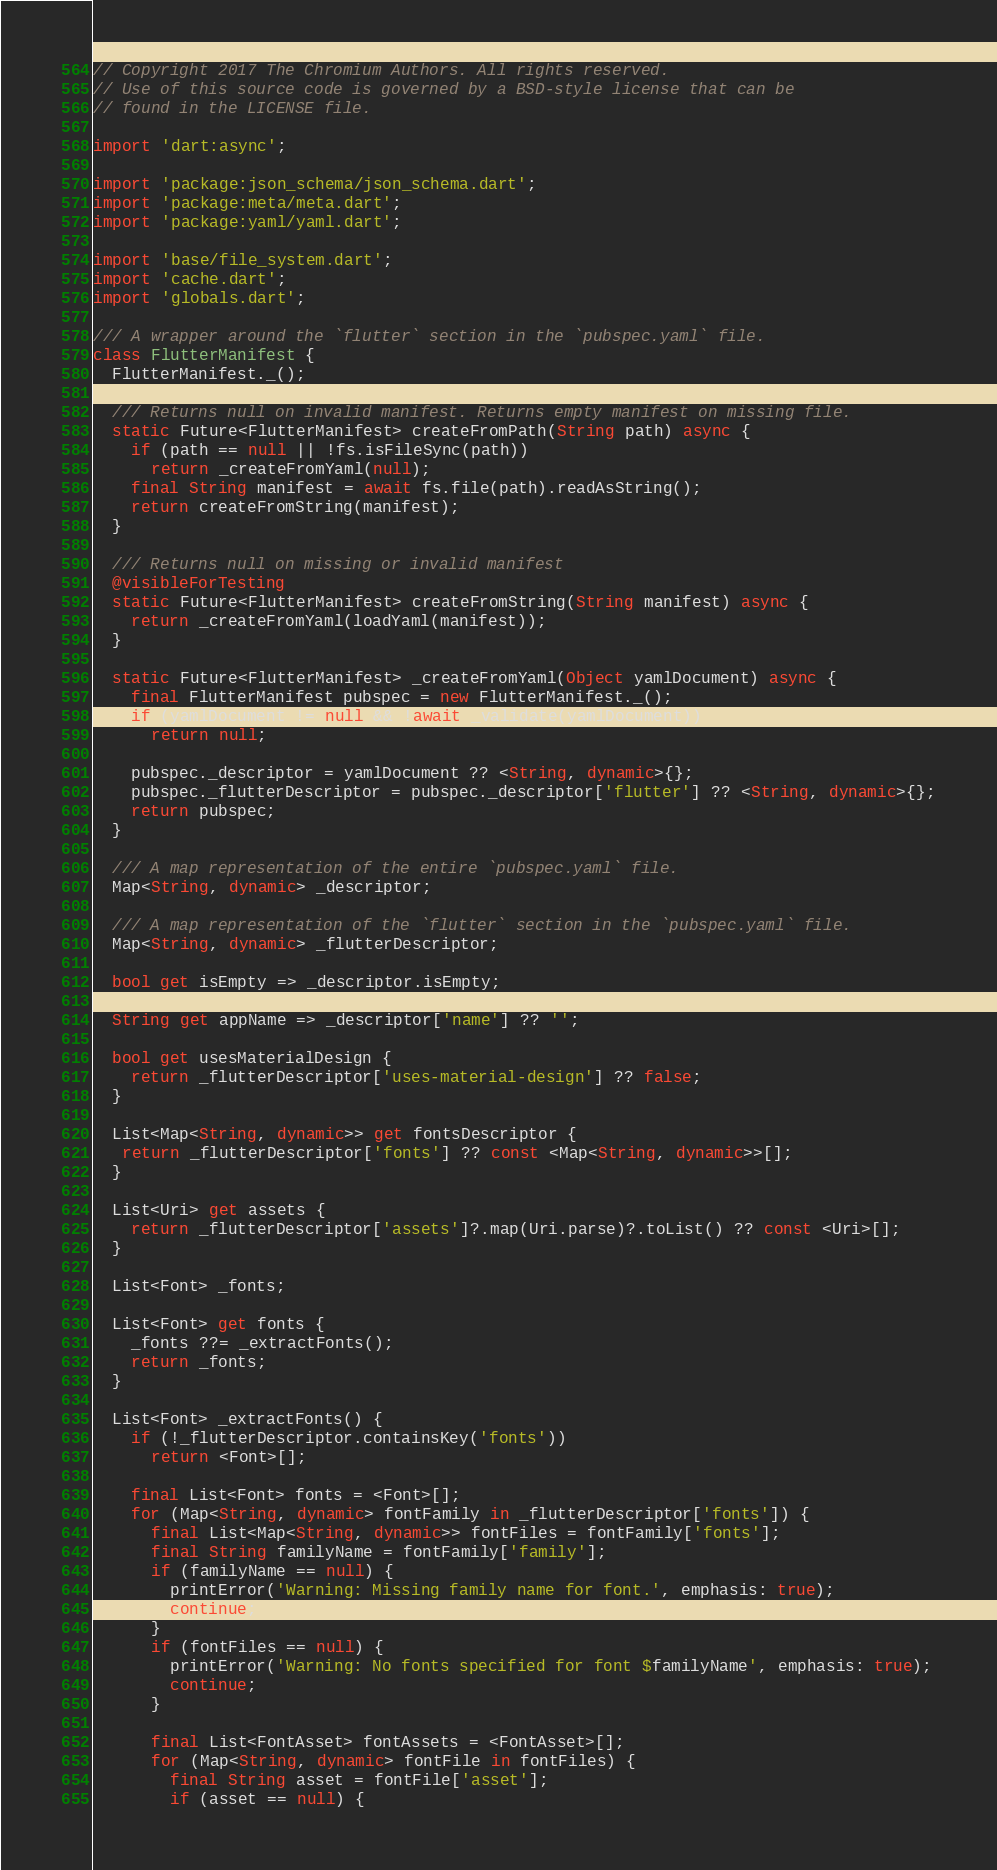Convert code to text. <code><loc_0><loc_0><loc_500><loc_500><_Dart_>// Copyright 2017 The Chromium Authors. All rights reserved.
// Use of this source code is governed by a BSD-style license that can be
// found in the LICENSE file.

import 'dart:async';

import 'package:json_schema/json_schema.dart';
import 'package:meta/meta.dart';
import 'package:yaml/yaml.dart';

import 'base/file_system.dart';
import 'cache.dart';
import 'globals.dart';

/// A wrapper around the `flutter` section in the `pubspec.yaml` file.
class FlutterManifest {
  FlutterManifest._();

  /// Returns null on invalid manifest. Returns empty manifest on missing file.
  static Future<FlutterManifest> createFromPath(String path) async {
    if (path == null || !fs.isFileSync(path))
      return _createFromYaml(null);
    final String manifest = await fs.file(path).readAsString();
    return createFromString(manifest);
  }

  /// Returns null on missing or invalid manifest
  @visibleForTesting
  static Future<FlutterManifest> createFromString(String manifest) async {
    return _createFromYaml(loadYaml(manifest));
  }

  static Future<FlutterManifest> _createFromYaml(Object yamlDocument) async {
    final FlutterManifest pubspec = new FlutterManifest._();
    if (yamlDocument != null && !await _validate(yamlDocument))
      return null;

    pubspec._descriptor = yamlDocument ?? <String, dynamic>{};
    pubspec._flutterDescriptor = pubspec._descriptor['flutter'] ?? <String, dynamic>{};
    return pubspec;
  }

  /// A map representation of the entire `pubspec.yaml` file.
  Map<String, dynamic> _descriptor;

  /// A map representation of the `flutter` section in the `pubspec.yaml` file.
  Map<String, dynamic> _flutterDescriptor;

  bool get isEmpty => _descriptor.isEmpty;

  String get appName => _descriptor['name'] ?? '';

  bool get usesMaterialDesign {
    return _flutterDescriptor['uses-material-design'] ?? false;
  }

  List<Map<String, dynamic>> get fontsDescriptor {
   return _flutterDescriptor['fonts'] ?? const <Map<String, dynamic>>[];
  }

  List<Uri> get assets {
    return _flutterDescriptor['assets']?.map(Uri.parse)?.toList() ?? const <Uri>[];
  }

  List<Font> _fonts;

  List<Font> get fonts {
    _fonts ??= _extractFonts();
    return _fonts;
  }

  List<Font> _extractFonts() {
    if (!_flutterDescriptor.containsKey('fonts'))
      return <Font>[];

    final List<Font> fonts = <Font>[];
    for (Map<String, dynamic> fontFamily in _flutterDescriptor['fonts']) {
      final List<Map<String, dynamic>> fontFiles = fontFamily['fonts'];
      final String familyName = fontFamily['family'];
      if (familyName == null) {
        printError('Warning: Missing family name for font.', emphasis: true);
        continue;
      }
      if (fontFiles == null) {
        printError('Warning: No fonts specified for font $familyName', emphasis: true);
        continue;
      }

      final List<FontAsset> fontAssets = <FontAsset>[];
      for (Map<String, dynamic> fontFile in fontFiles) {
        final String asset = fontFile['asset'];
        if (asset == null) {</code> 